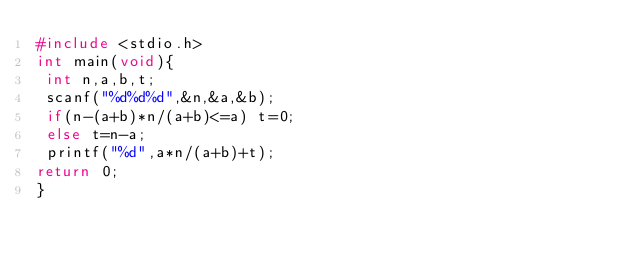Convert code to text. <code><loc_0><loc_0><loc_500><loc_500><_C_>#include <stdio.h>
int main(void){
 int n,a,b,t;
 scanf("%d%d%d",&n,&a,&b);
 if(n-(a+b)*n/(a+b)<=a) t=0;
 else t=n-a;
 printf("%d",a*n/(a+b)+t);
return 0;
}
</code> 